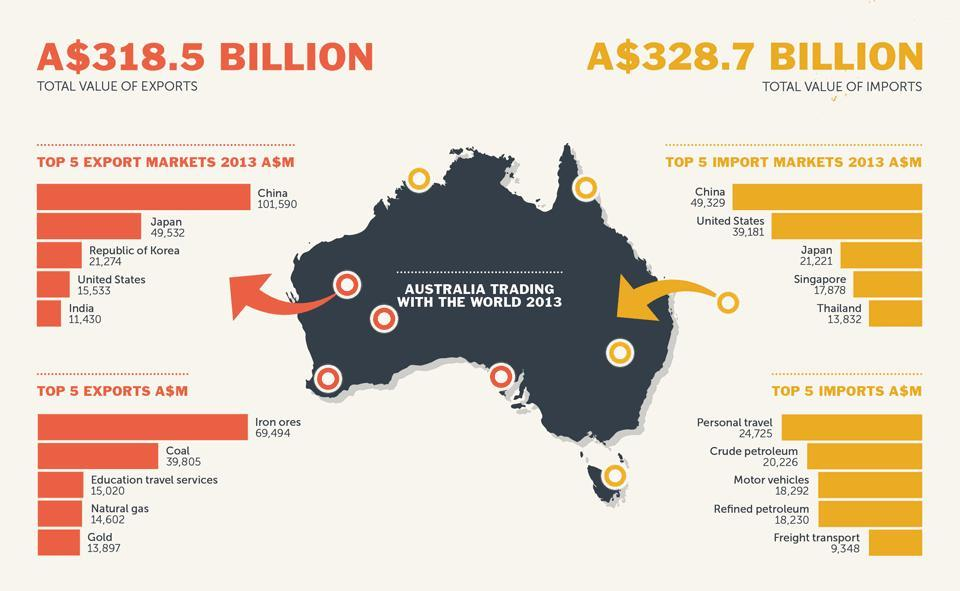Which is the top most metal exported by Australia?
Answer the question with a short phrase. Gold How much is the difference in export to United States and India from Australia? 4,103 How much Australia spend for importing Refined Petroleum? 18,230 Which is the third highest export market of Australia? Republic of Korea Which is the second most product imported by Australia? Crude Petroleum How much is the value of Import of Australia from China? 49,329 What is the total value of imports? A$328.7 Which country has the second least position while considering the import markets of Australia? Singapore Which commodity is the second most exported item of Australia? Coal Which is the second highest export market of Australia? Japan 